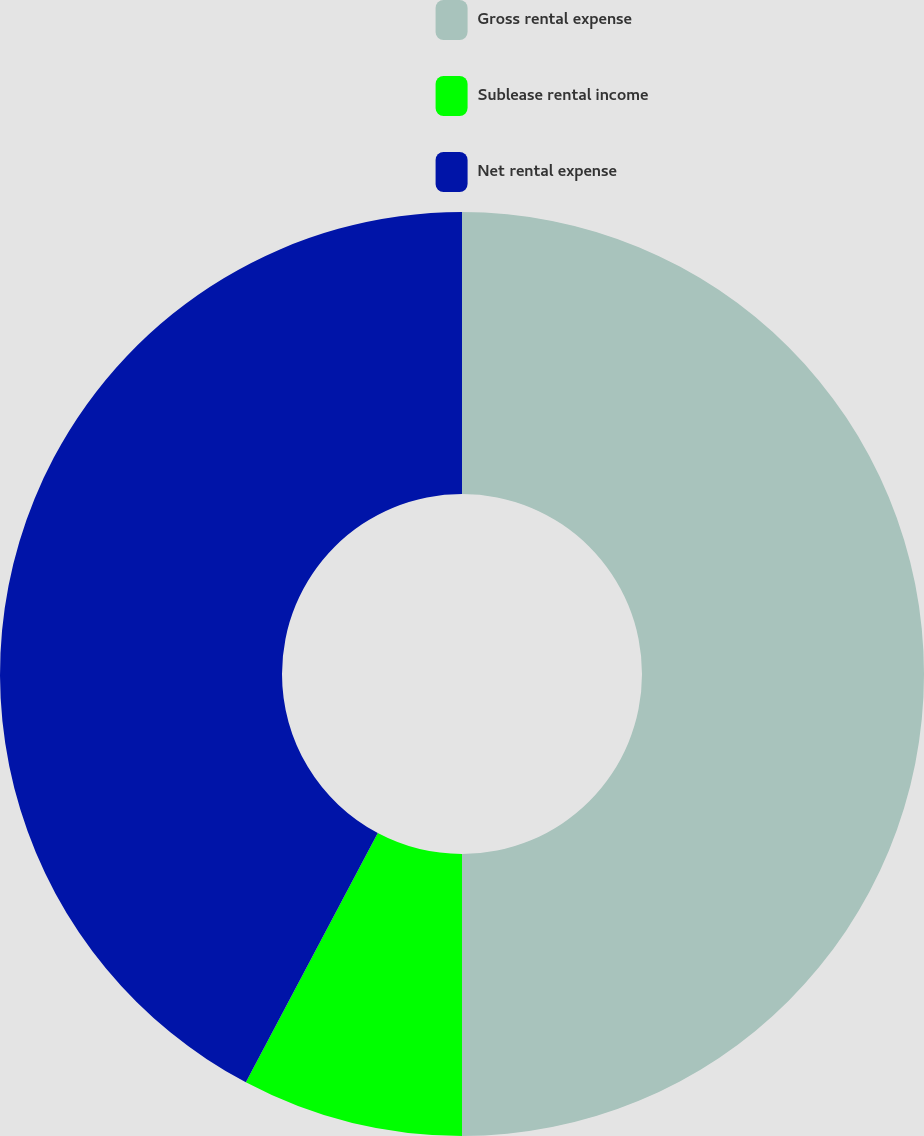Convert chart. <chart><loc_0><loc_0><loc_500><loc_500><pie_chart><fcel>Gross rental expense<fcel>Sublease rental income<fcel>Net rental expense<nl><fcel>50.0%<fcel>7.75%<fcel>42.25%<nl></chart> 